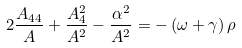Convert formula to latex. <formula><loc_0><loc_0><loc_500><loc_500>2 \frac { A _ { 4 4 } } { A } + \frac { A _ { 4 } ^ { 2 } } { A ^ { 2 } } - \frac { \alpha ^ { 2 } } { A ^ { 2 } } = - \left ( \omega + \gamma \right ) \rho</formula> 